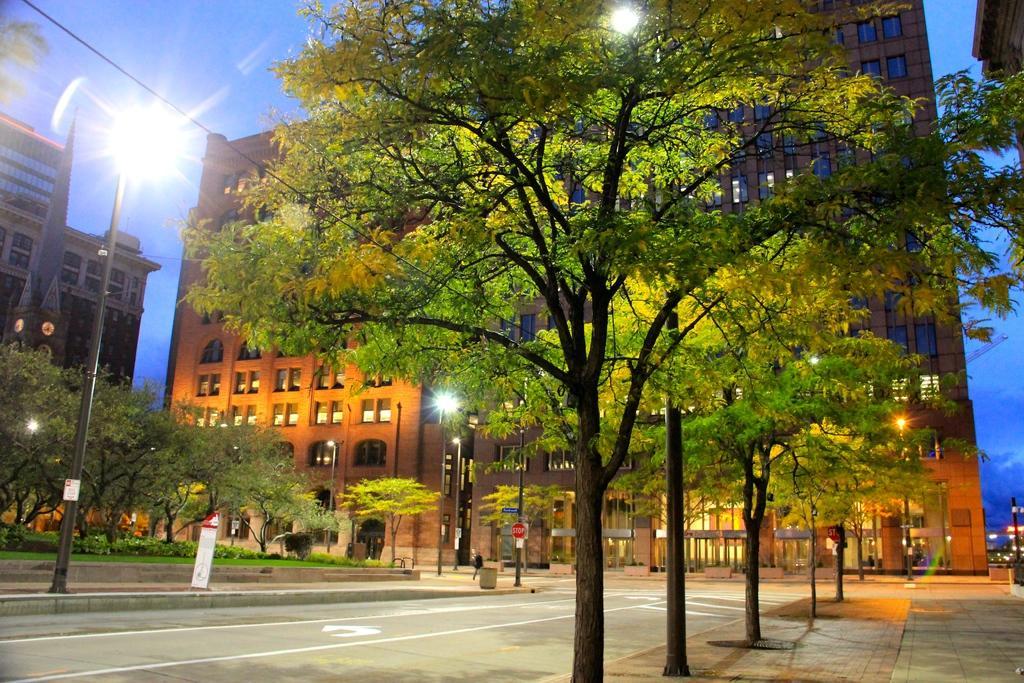Describe this image in one or two sentences. In this picture we can see trees, road, poles, lights, grass, wire and plants. In the background of the image we can see buildings and sky. 